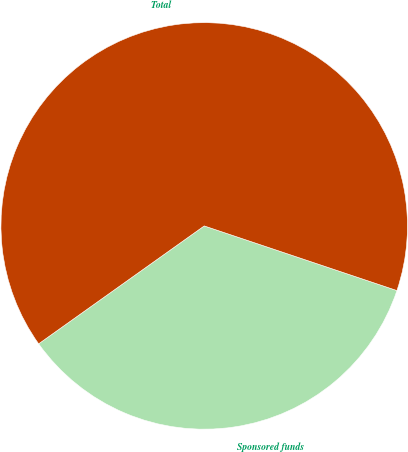Convert chart to OTSL. <chart><loc_0><loc_0><loc_500><loc_500><pie_chart><fcel>Sponsored funds<fcel>Total<nl><fcel>35.0%<fcel>65.0%<nl></chart> 